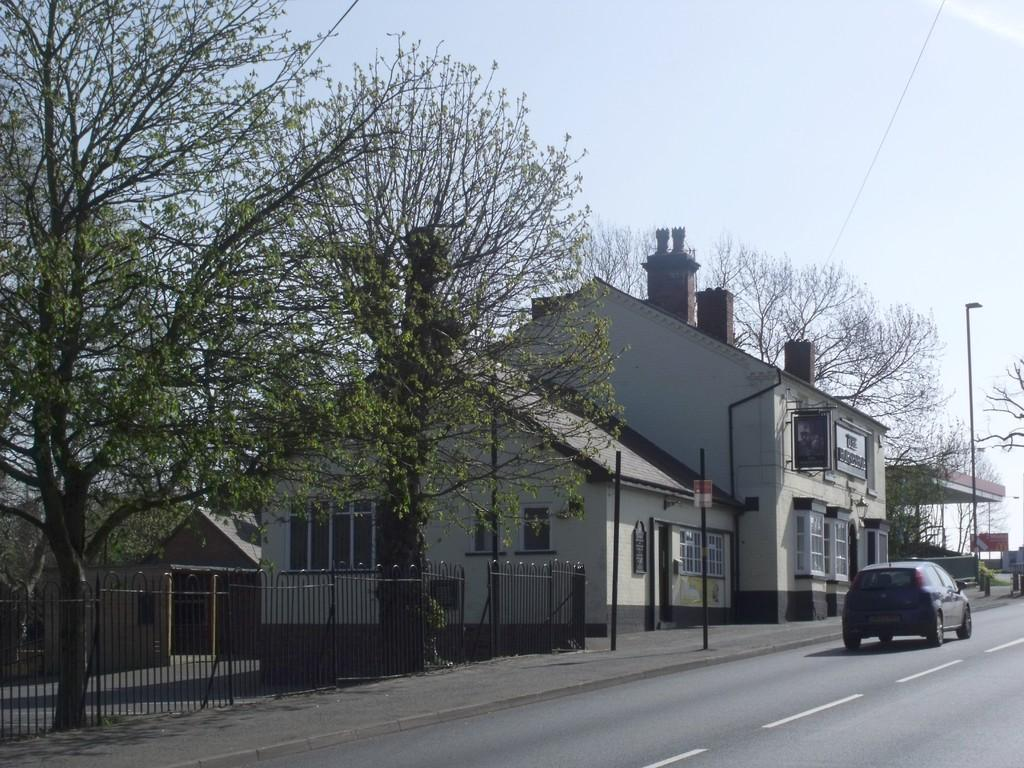What is the main subject of the image? The main subject of the image is a car. Where is the car located in the image? The car is on a road. What can be seen beside the road in the image? There are buildings beside the road. What type of vegetation is present on either side of the road? Trees are present on either side of the road. What is visible above the road in the image? The sky is visible above the road. How does the car's sister feel about the car's fuel efficiency? There is no mention of a car's sister or fuel efficiency in the image, so it is not possible to answer that question. 